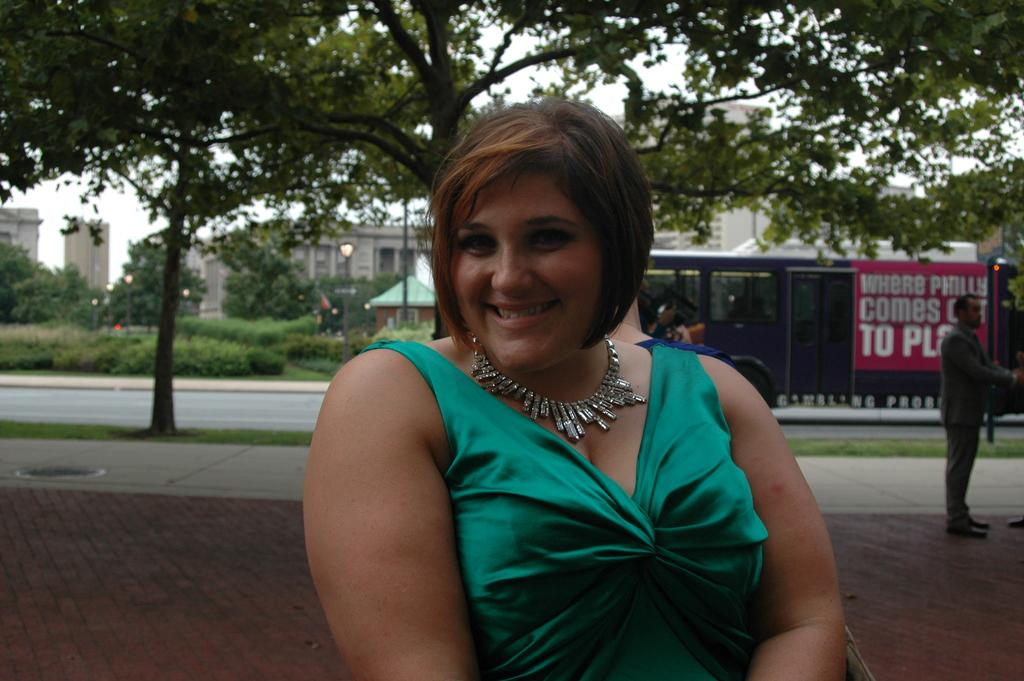What is the main subject of the image? There is a woman standing on the road in the center of the image. What can be seen in the background of the image? In the background, there are trees, plants, vehicles, a road, people, buildings, and the sky. Can you describe the environment in the image? The image shows a woman standing on a road surrounded by trees, plants, and buildings, with vehicles and people in the background. The sky is also visible. What does the woman's dad think about her standing on the road in the image? There is no information about the woman's dad or his opinion in the image. What territory does the woman claim by standing on the road in the image? The image does not depict any territorial claims or disputes. 